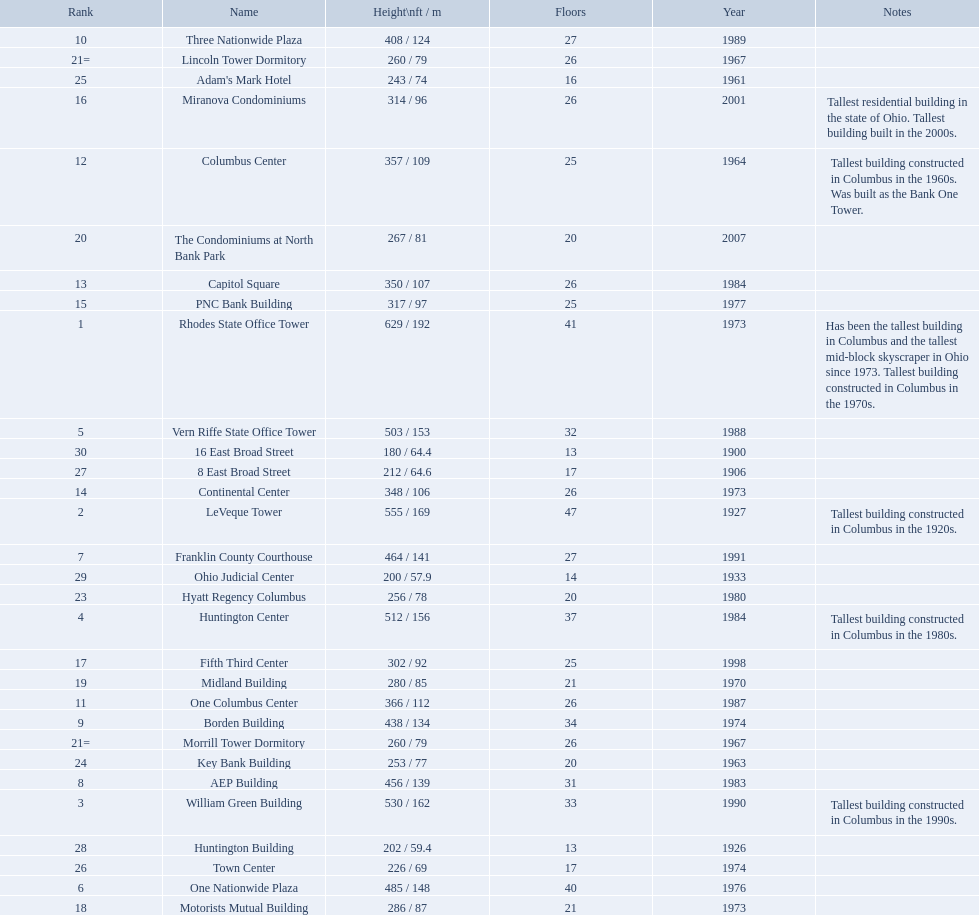Which of the tallest buildings in columbus, ohio were built in the 1980s? Huntington Center, Vern Riffe State Office Tower, AEP Building, Three Nationwide Plaza, One Columbus Center, Capitol Square, Hyatt Regency Columbus. Of these buildings, which have between 26 and 31 floors? AEP Building, Three Nationwide Plaza, One Columbus Center, Capitol Square. Of these buildings, which is the tallest? AEP Building. 